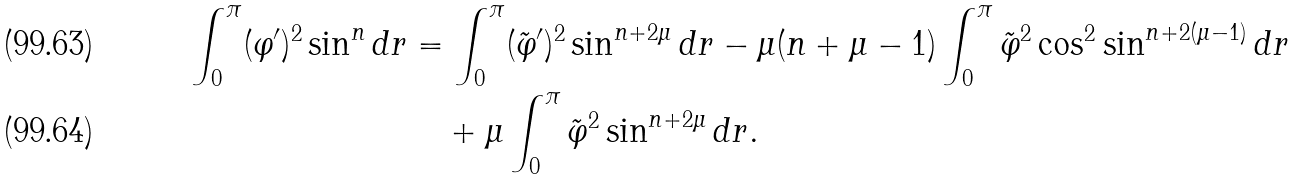Convert formula to latex. <formula><loc_0><loc_0><loc_500><loc_500>\int _ { 0 } ^ { \pi } ( \varphi ^ { \prime } ) ^ { 2 } \sin ^ { n } d r & = \int _ { 0 } ^ { \pi } ( \tilde { \varphi } ^ { \prime } ) ^ { 2 } \sin ^ { n + 2 \mu } d r - \mu ( n + \mu - 1 ) \int _ { 0 } ^ { \pi } \tilde { \varphi } ^ { 2 } \cos ^ { 2 } \sin ^ { n + 2 ( \mu - 1 ) } d r \\ & \quad + \mu \int _ { 0 } ^ { \pi } \tilde { \varphi } ^ { 2 } \sin ^ { n + 2 \mu } d r .</formula> 